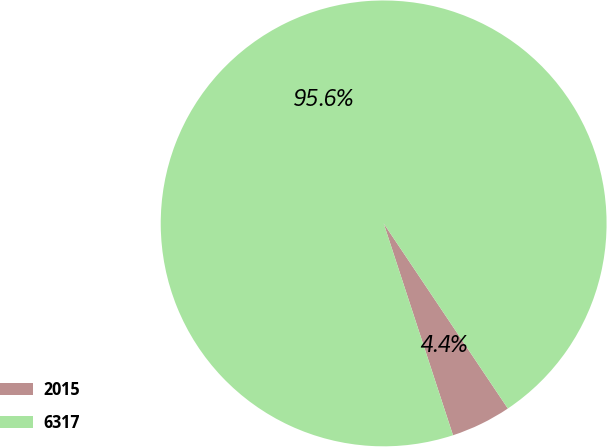<chart> <loc_0><loc_0><loc_500><loc_500><pie_chart><fcel>2015<fcel>6317<nl><fcel>4.37%<fcel>95.63%<nl></chart> 